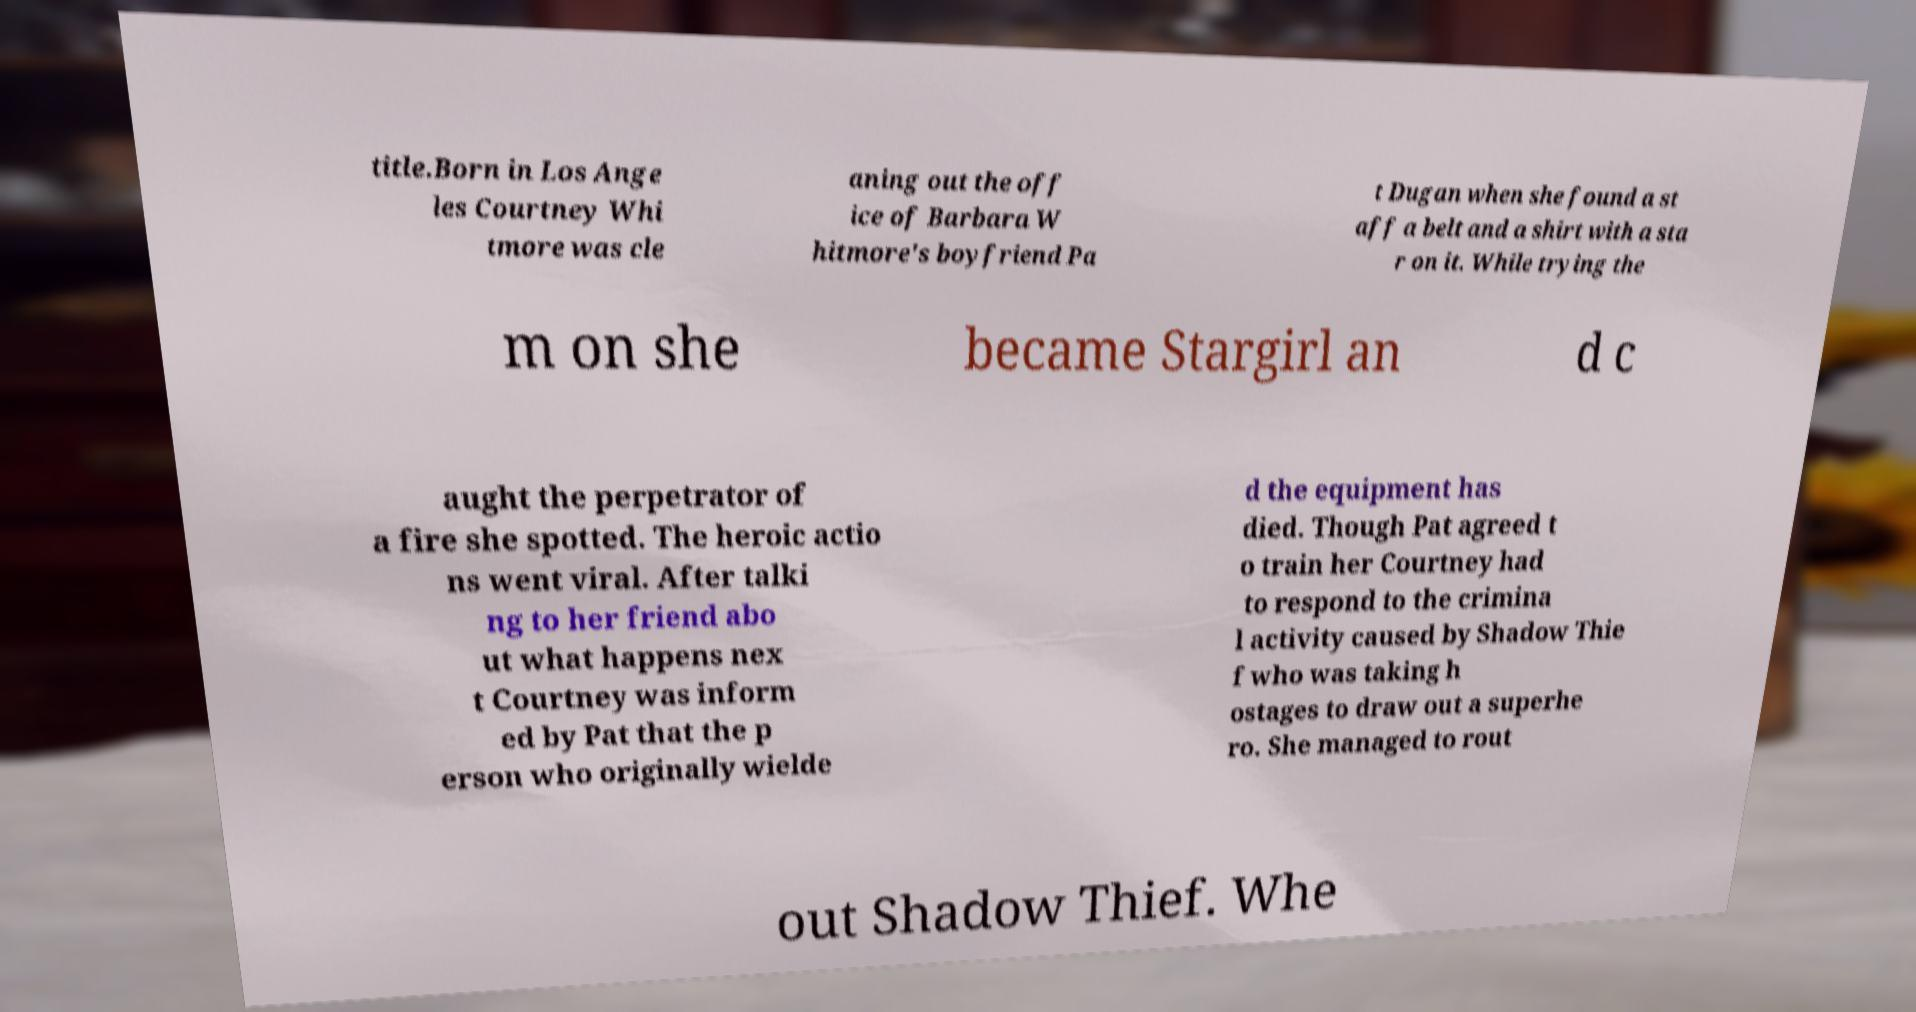What messages or text are displayed in this image? I need them in a readable, typed format. title.Born in Los Ange les Courtney Whi tmore was cle aning out the off ice of Barbara W hitmore's boyfriend Pa t Dugan when she found a st aff a belt and a shirt with a sta r on it. While trying the m on she became Stargirl an d c aught the perpetrator of a fire she spotted. The heroic actio ns went viral. After talki ng to her friend abo ut what happens nex t Courtney was inform ed by Pat that the p erson who originally wielde d the equipment has died. Though Pat agreed t o train her Courtney had to respond to the crimina l activity caused by Shadow Thie f who was taking h ostages to draw out a superhe ro. She managed to rout out Shadow Thief. Whe 